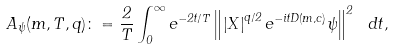<formula> <loc_0><loc_0><loc_500><loc_500>A _ { \psi } ( m , T , q ) \colon = \frac { 2 } { T } \int _ { 0 } ^ { \infty } { e ^ { - 2 t / T } } \left \| \left | X \right | ^ { q / 2 } e ^ { - i t D ( m , c ) } \psi \right \| ^ { 2 } \ d t ,</formula> 